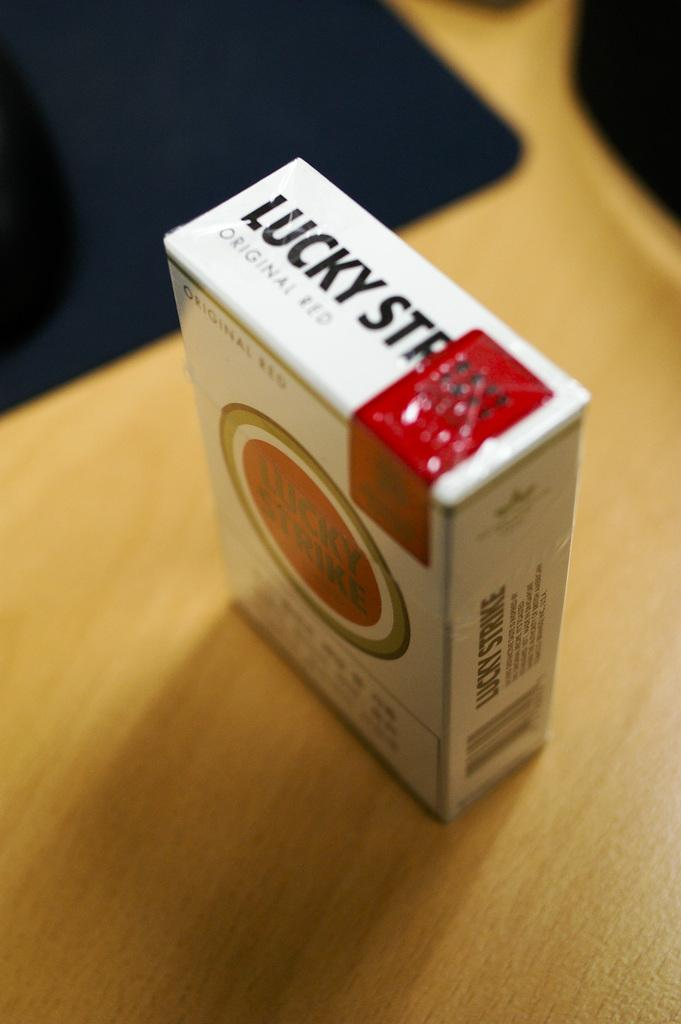<image>
Create a compact narrative representing the image presented. A box of Lucky Strike cigarettes sits on a wooden table. 